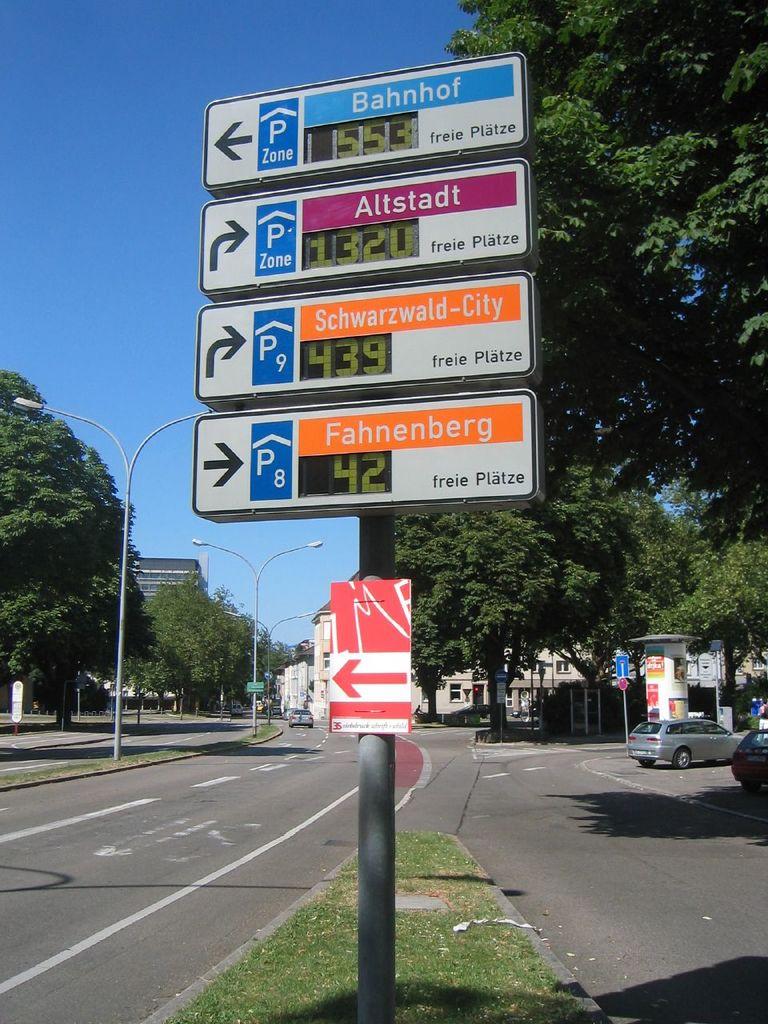What is the location on the blue sign?
Keep it short and to the point. Bahnhof. What number can be seen in the very bottom sign?
Your answer should be very brief. 42. 